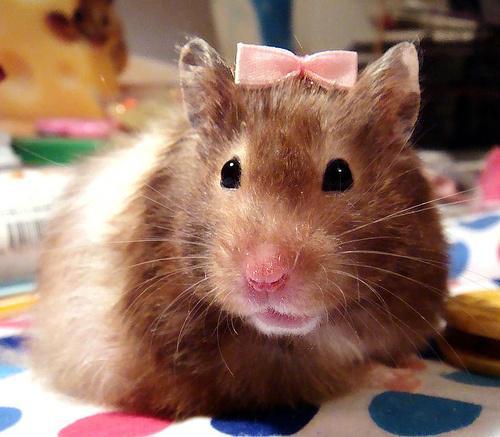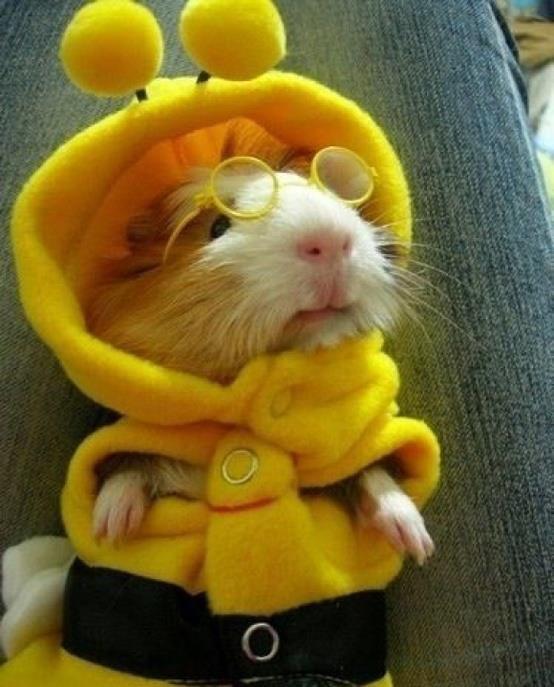The first image is the image on the left, the second image is the image on the right. Assess this claim about the two images: "Little animals are shown with tiny musical instruments and an audition sign.". Correct or not? Answer yes or no. No. The first image is the image on the left, the second image is the image on the right. Assess this claim about the two images: "There are only two mice and they are both wearing something on their heads.". Correct or not? Answer yes or no. Yes. 